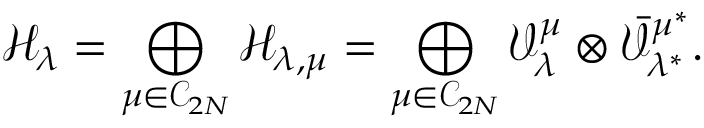Convert formula to latex. <formula><loc_0><loc_0><loc_500><loc_500>\mathcal { H } _ { \lambda } = \bigoplus _ { \mu \in \mathcal { C } _ { 2 N } } \mathcal { H } _ { \lambda , \mu } = \bigoplus _ { \mu \in \mathcal { C } _ { 2 N } } \mathcal { V } _ { \lambda } ^ { \mu } \otimes \bar { \mathcal { V } } _ { \lambda ^ { * } } ^ { \mu ^ { * } } .</formula> 